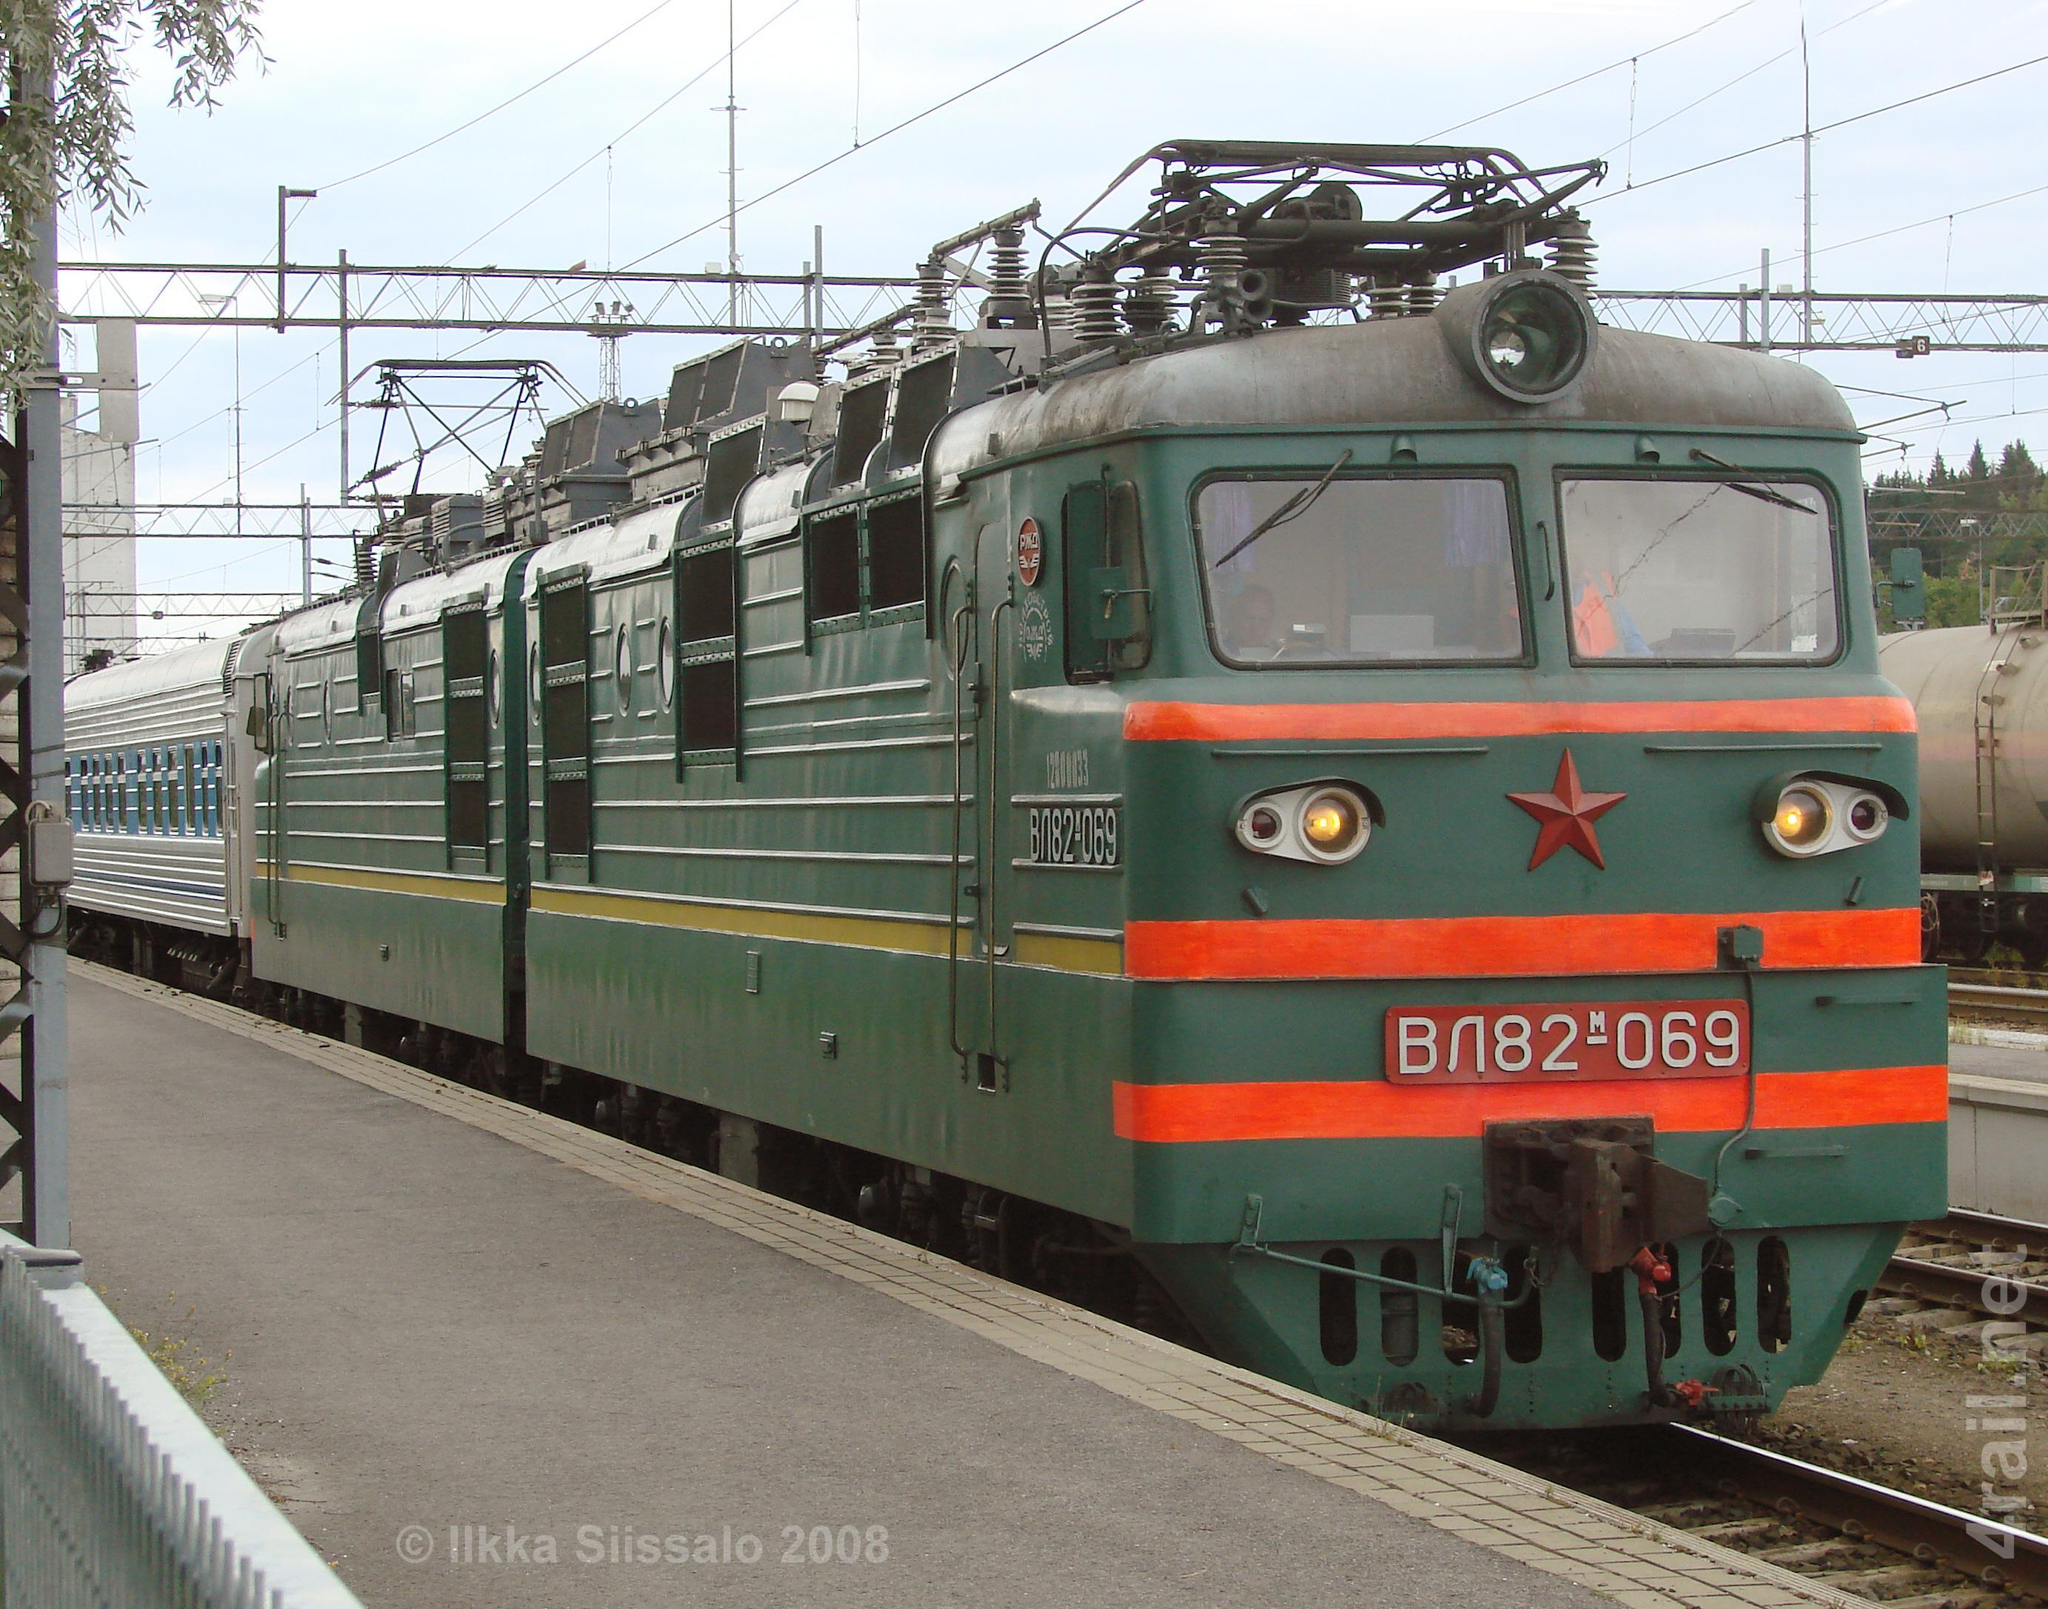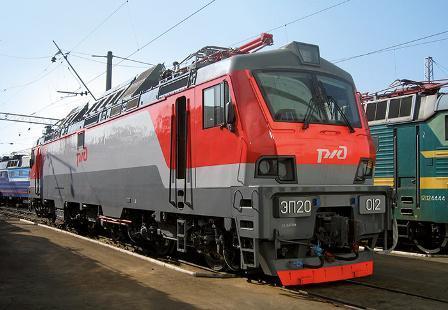The first image is the image on the left, the second image is the image on the right. For the images displayed, is the sentence "An image shows a dark green train with bright orange stripes across the front." factually correct? Answer yes or no. Yes. 